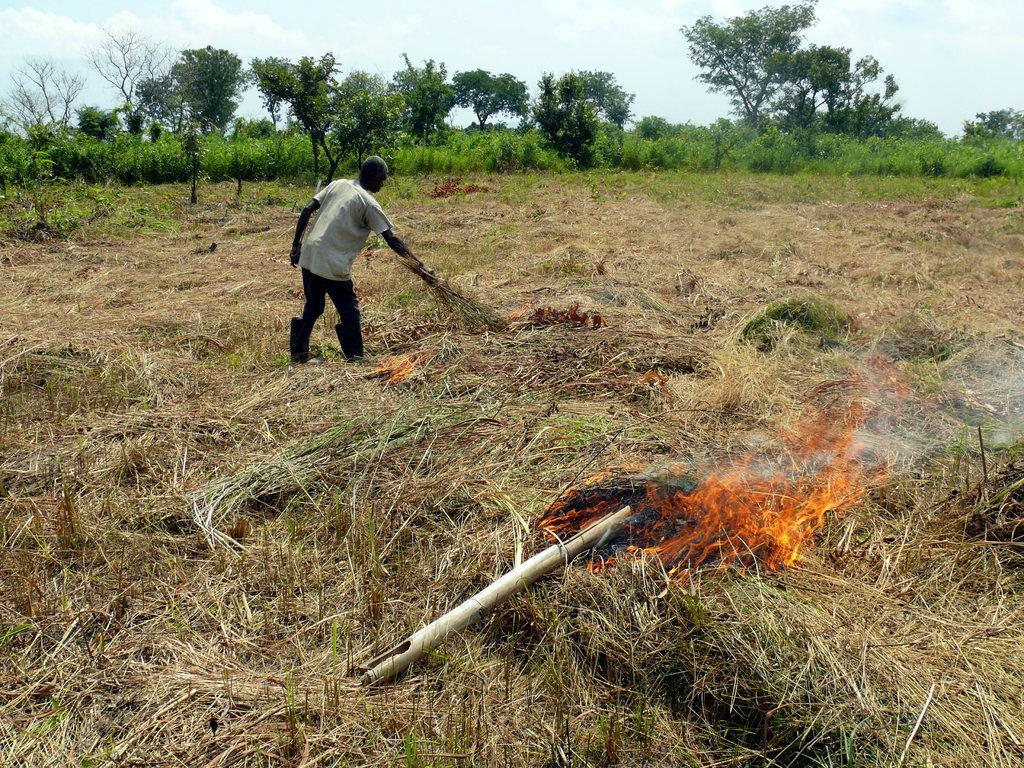Describe this image in one or two sentences. In the foreground of the image we can see grass which is lighting. In the middle of the image we can see a person is bending and holding some grass in his hand. On the top of the image we can see the sky and trees. 